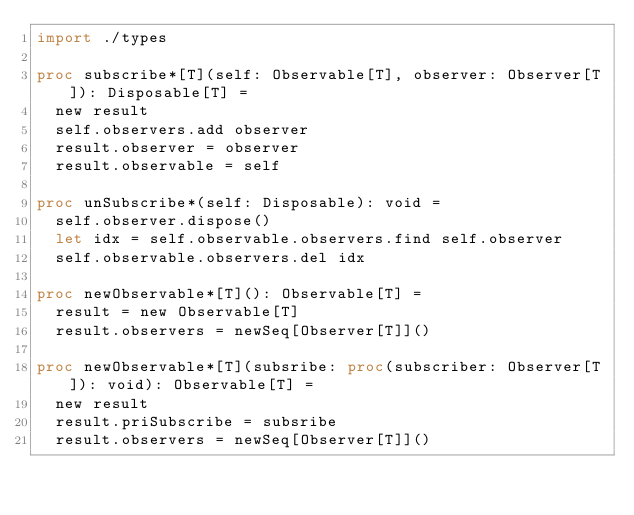<code> <loc_0><loc_0><loc_500><loc_500><_Nim_>import ./types

proc subscribe*[T](self: Observable[T], observer: Observer[T]): Disposable[T] =
  new result
  self.observers.add observer
  result.observer = observer
  result.observable = self

proc unSubscribe*(self: Disposable): void =
  self.observer.dispose()
  let idx = self.observable.observers.find self.observer
  self.observable.observers.del idx

proc newObservable*[T](): Observable[T] =
  result = new Observable[T]
  result.observers = newSeq[Observer[T]]()

proc newObservable*[T](subsribe: proc(subscriber: Observer[T]): void): Observable[T] =
  new result
  result.priSubscribe = subsribe
  result.observers = newSeq[Observer[T]]()
</code> 